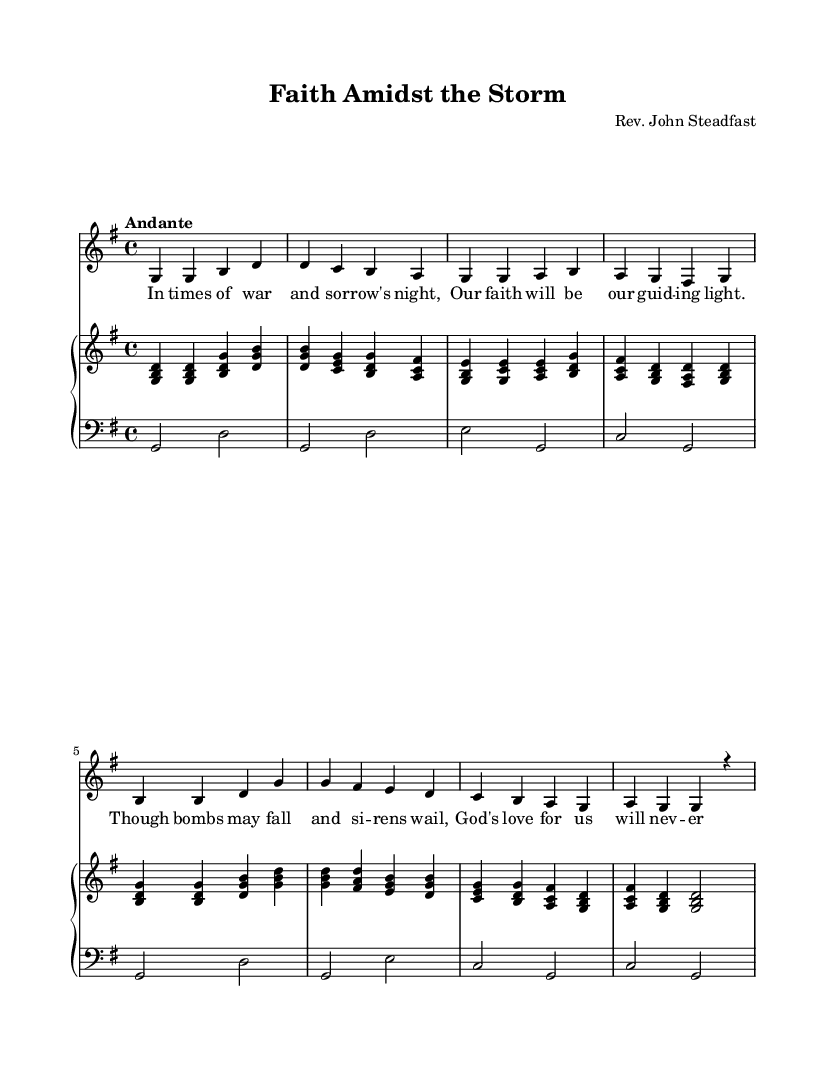What is the key signature of this music? The key signature is G major, which has one sharp (F#). This is indicated at the beginning of the sheet music.
Answer: G major What is the time signature of this music? The time signature is 4/4, which means there are four beats per measure. This is shown at the beginning of the sheet music.
Answer: 4/4 What is the tempo marking for this piece? The tempo marking is "Andante," indicating a moderate pace. It is written at the beginning of the music near the time signature.
Answer: Andante How many measures does the melody contain? The melody comprises 8 measures. Each measure is separated by vertical lines, making it easy to count the total.
Answer: 8 What is the title of this hymn? The title is "Faith Amidst the Storm," which is clearly presented at the top of the sheet music under the header section.
Answer: Faith Amidst the Storm What is the clef used in the lower staff? The lower staff uses the bass clef, which is indicated by the clef symbol at the beginning of that staff.
Answer: Bass What lyric corresponds to the first measure of the melody? The first measure corresponds to the lyrics "In times of war and sor row's night," which are aligned directly under the melody notes in the score.
Answer: In times of war and sorrow's night 